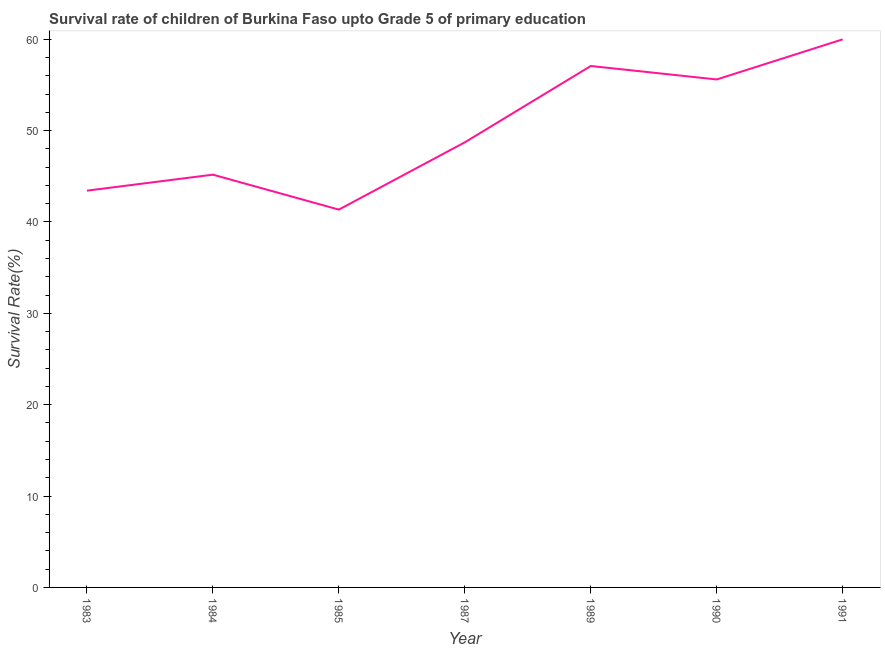What is the survival rate in 1989?
Offer a very short reply. 57.07. Across all years, what is the maximum survival rate?
Offer a very short reply. 59.99. Across all years, what is the minimum survival rate?
Offer a terse response. 41.35. In which year was the survival rate maximum?
Make the answer very short. 1991. What is the sum of the survival rate?
Offer a very short reply. 351.33. What is the difference between the survival rate in 1983 and 1985?
Give a very brief answer. 2.07. What is the average survival rate per year?
Your answer should be very brief. 50.19. What is the median survival rate?
Make the answer very short. 48.72. Do a majority of the years between 1990 and 1989 (inclusive) have survival rate greater than 58 %?
Your answer should be very brief. No. What is the ratio of the survival rate in 1984 to that in 1985?
Make the answer very short. 1.09. Is the survival rate in 1985 less than that in 1991?
Offer a terse response. Yes. What is the difference between the highest and the second highest survival rate?
Provide a succinct answer. 2.92. Is the sum of the survival rate in 1983 and 1989 greater than the maximum survival rate across all years?
Provide a short and direct response. Yes. What is the difference between the highest and the lowest survival rate?
Your response must be concise. 18.64. In how many years, is the survival rate greater than the average survival rate taken over all years?
Your response must be concise. 3. How many lines are there?
Your answer should be very brief. 1. How many years are there in the graph?
Offer a terse response. 7. Does the graph contain any zero values?
Your response must be concise. No. Does the graph contain grids?
Provide a short and direct response. No. What is the title of the graph?
Your answer should be compact. Survival rate of children of Burkina Faso upto Grade 5 of primary education. What is the label or title of the Y-axis?
Provide a short and direct response. Survival Rate(%). What is the Survival Rate(%) in 1983?
Your answer should be compact. 43.43. What is the Survival Rate(%) in 1984?
Give a very brief answer. 45.18. What is the Survival Rate(%) of 1985?
Your answer should be very brief. 41.35. What is the Survival Rate(%) in 1987?
Ensure brevity in your answer.  48.72. What is the Survival Rate(%) in 1989?
Provide a succinct answer. 57.07. What is the Survival Rate(%) of 1990?
Provide a short and direct response. 55.6. What is the Survival Rate(%) in 1991?
Ensure brevity in your answer.  59.99. What is the difference between the Survival Rate(%) in 1983 and 1984?
Make the answer very short. -1.75. What is the difference between the Survival Rate(%) in 1983 and 1985?
Your answer should be very brief. 2.07. What is the difference between the Survival Rate(%) in 1983 and 1987?
Give a very brief answer. -5.29. What is the difference between the Survival Rate(%) in 1983 and 1989?
Offer a very short reply. -13.65. What is the difference between the Survival Rate(%) in 1983 and 1990?
Ensure brevity in your answer.  -12.17. What is the difference between the Survival Rate(%) in 1983 and 1991?
Your answer should be very brief. -16.56. What is the difference between the Survival Rate(%) in 1984 and 1985?
Provide a short and direct response. 3.82. What is the difference between the Survival Rate(%) in 1984 and 1987?
Your answer should be very brief. -3.54. What is the difference between the Survival Rate(%) in 1984 and 1989?
Give a very brief answer. -11.89. What is the difference between the Survival Rate(%) in 1984 and 1990?
Provide a succinct answer. -10.42. What is the difference between the Survival Rate(%) in 1984 and 1991?
Your response must be concise. -14.81. What is the difference between the Survival Rate(%) in 1985 and 1987?
Keep it short and to the point. -7.36. What is the difference between the Survival Rate(%) in 1985 and 1989?
Make the answer very short. -15.72. What is the difference between the Survival Rate(%) in 1985 and 1990?
Make the answer very short. -14.25. What is the difference between the Survival Rate(%) in 1985 and 1991?
Give a very brief answer. -18.64. What is the difference between the Survival Rate(%) in 1987 and 1989?
Your answer should be very brief. -8.35. What is the difference between the Survival Rate(%) in 1987 and 1990?
Provide a short and direct response. -6.88. What is the difference between the Survival Rate(%) in 1987 and 1991?
Ensure brevity in your answer.  -11.27. What is the difference between the Survival Rate(%) in 1989 and 1990?
Your response must be concise. 1.47. What is the difference between the Survival Rate(%) in 1989 and 1991?
Give a very brief answer. -2.92. What is the difference between the Survival Rate(%) in 1990 and 1991?
Offer a terse response. -4.39. What is the ratio of the Survival Rate(%) in 1983 to that in 1987?
Make the answer very short. 0.89. What is the ratio of the Survival Rate(%) in 1983 to that in 1989?
Keep it short and to the point. 0.76. What is the ratio of the Survival Rate(%) in 1983 to that in 1990?
Give a very brief answer. 0.78. What is the ratio of the Survival Rate(%) in 1983 to that in 1991?
Give a very brief answer. 0.72. What is the ratio of the Survival Rate(%) in 1984 to that in 1985?
Offer a very short reply. 1.09. What is the ratio of the Survival Rate(%) in 1984 to that in 1987?
Provide a short and direct response. 0.93. What is the ratio of the Survival Rate(%) in 1984 to that in 1989?
Ensure brevity in your answer.  0.79. What is the ratio of the Survival Rate(%) in 1984 to that in 1990?
Your answer should be very brief. 0.81. What is the ratio of the Survival Rate(%) in 1984 to that in 1991?
Make the answer very short. 0.75. What is the ratio of the Survival Rate(%) in 1985 to that in 1987?
Keep it short and to the point. 0.85. What is the ratio of the Survival Rate(%) in 1985 to that in 1989?
Provide a short and direct response. 0.72. What is the ratio of the Survival Rate(%) in 1985 to that in 1990?
Provide a succinct answer. 0.74. What is the ratio of the Survival Rate(%) in 1985 to that in 1991?
Offer a very short reply. 0.69. What is the ratio of the Survival Rate(%) in 1987 to that in 1989?
Provide a succinct answer. 0.85. What is the ratio of the Survival Rate(%) in 1987 to that in 1990?
Your answer should be very brief. 0.88. What is the ratio of the Survival Rate(%) in 1987 to that in 1991?
Your answer should be very brief. 0.81. What is the ratio of the Survival Rate(%) in 1989 to that in 1990?
Make the answer very short. 1.03. What is the ratio of the Survival Rate(%) in 1989 to that in 1991?
Your answer should be very brief. 0.95. What is the ratio of the Survival Rate(%) in 1990 to that in 1991?
Make the answer very short. 0.93. 